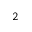<formula> <loc_0><loc_0><loc_500><loc_500>_ { 2 }</formula> 